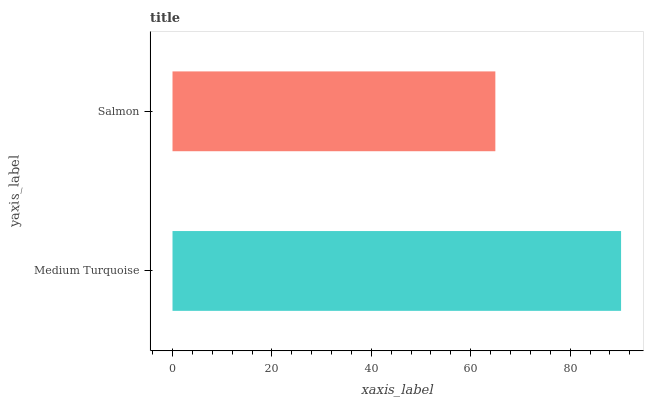Is Salmon the minimum?
Answer yes or no. Yes. Is Medium Turquoise the maximum?
Answer yes or no. Yes. Is Salmon the maximum?
Answer yes or no. No. Is Medium Turquoise greater than Salmon?
Answer yes or no. Yes. Is Salmon less than Medium Turquoise?
Answer yes or no. Yes. Is Salmon greater than Medium Turquoise?
Answer yes or no. No. Is Medium Turquoise less than Salmon?
Answer yes or no. No. Is Medium Turquoise the high median?
Answer yes or no. Yes. Is Salmon the low median?
Answer yes or no. Yes. Is Salmon the high median?
Answer yes or no. No. Is Medium Turquoise the low median?
Answer yes or no. No. 